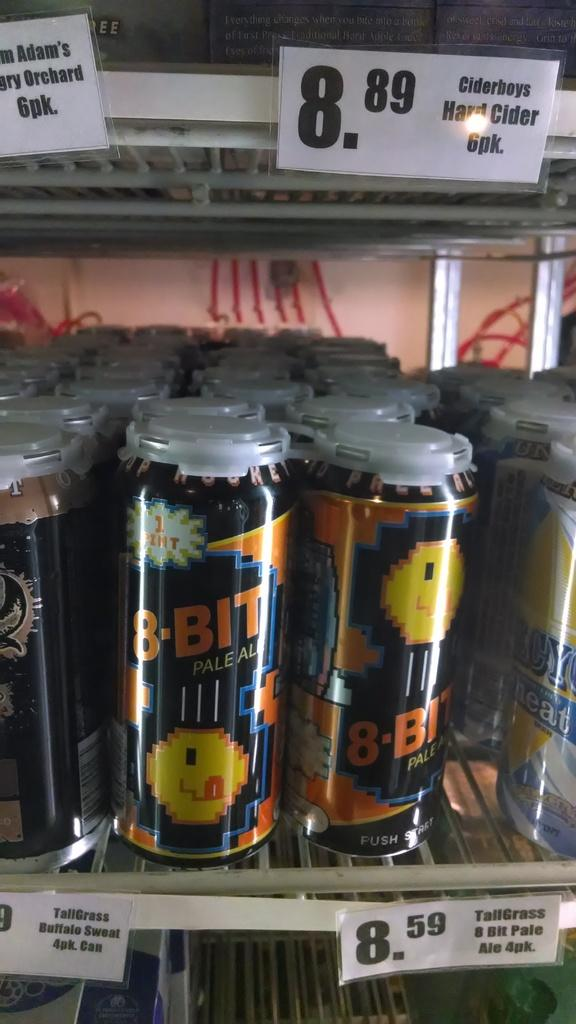Provide a one-sentence caption for the provided image. A 4 pack of TallGrass 8 bit pale ale costs 8,59. 